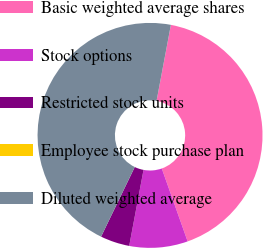Convert chart to OTSL. <chart><loc_0><loc_0><loc_500><loc_500><pie_chart><fcel>Basic weighted average shares<fcel>Stock options<fcel>Restricted stock units<fcel>Employee stock purchase plan<fcel>Diluted weighted average<nl><fcel>41.61%<fcel>8.39%<fcel>4.2%<fcel>0.0%<fcel>45.8%<nl></chart> 